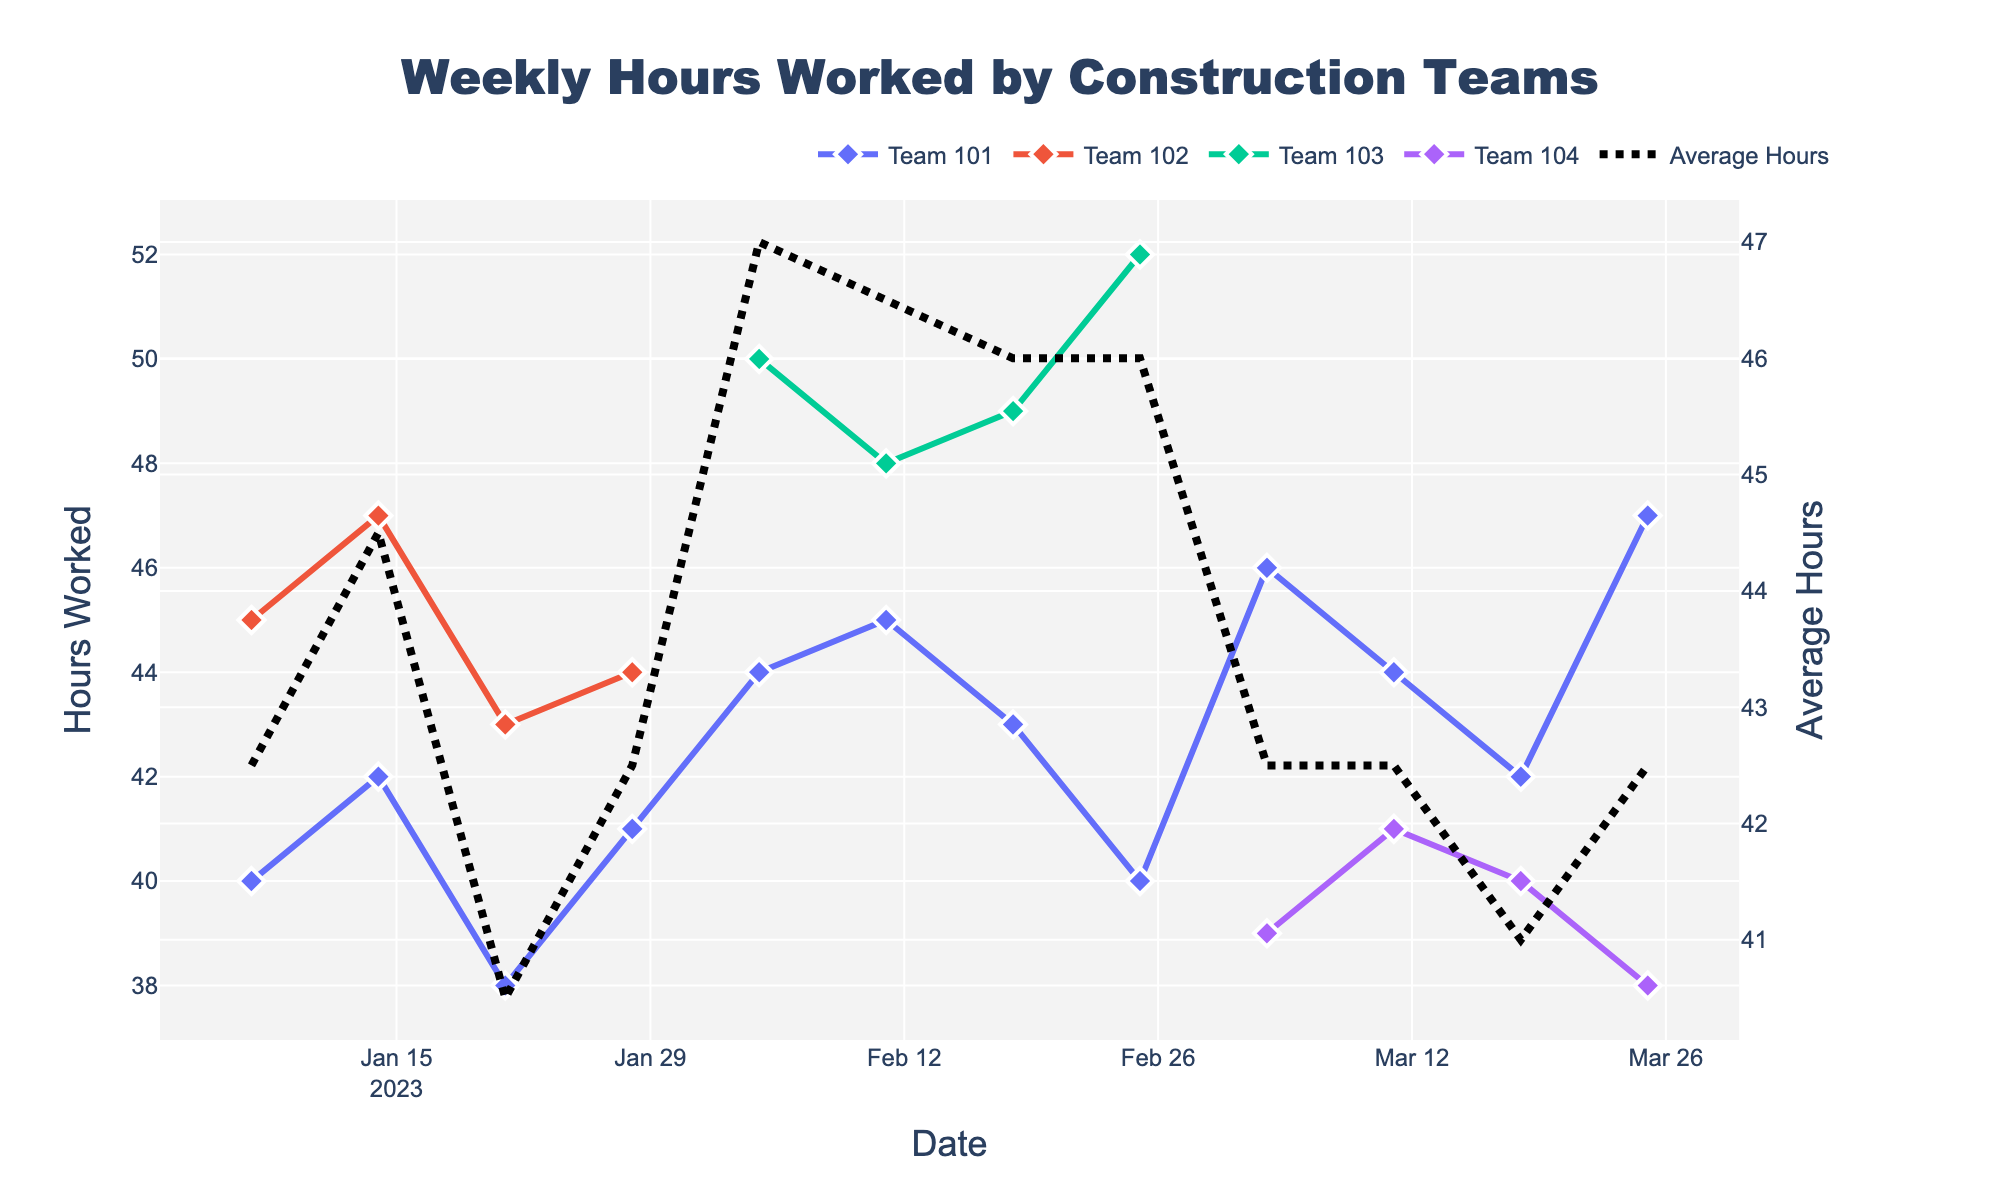What is the title of the figure? The title is located at the top of the figure. It is a text element that describes the content of the plot.
Answer: Weekly Hours Worked by Construction Teams How many teams are represented in the figure? The legend at the top right of the figure shows different teams by their unique colors and names (Team 101, Team 102, Team 103, Team 104).
Answer: Four teams Which team worked the most hours in the entire time period? By observing the lines and markers in the plot, look for the highest data points. Team 103 has the highest hours worked in the time period, peaking at 52 hours.
Answer: Team 103 What is the trend for Team 101's hours worked over time? Follow Team 101’s line in the plot across time, noting the peaks and valleys. Initially, hours fluctuate but generally tend to increase over time with minor dips.
Answer: Fluctuating, generally increasing What was the average number of hours worked on 2023-02-25? Locate the vertical line at 2023-02-25 and find the value represented by the black dashed line which shows the average hours worked on this date.
Answer: 44 hours How do the hours worked on 2023-01-07 compare between Team 101 and Team 102? Observe both data points for January 7, compare their positions; Team 101 worked 40 hours, and Team 102 worked 45 hours.
Answer: Team 102 worked 5 hours more What patterns can you observe about hourly work differences between urban and highway locations? Examine the locations specified in the legend and corresponding lines on the plot. Generally, urban projects have more hours worked compared to highway projects.
Answer: Urban areas generally have more hours Did Team 104 ever work more hours than Team 101 on any given week? Trace both teams' lines and compare their values each week. Team 104 worked less or equal hours compared to Team 101 throughout the period shown.
Answer: No What is the average hours worked throughout the period for Team 101? Calculate the mean of the points on Team 101's line: (40+42+38+41+44+45+43+40+46+44+42+47)/12. Perform the arithmetic operations sequentially.
Answer: 42.67 hours Which week showed the highest overall average hours worked by all teams? Identify the highest point on the black dashed line (average hours worked), and note the corresponding date. This occurs on 2023-02-25.
Answer: 2023-02-25 